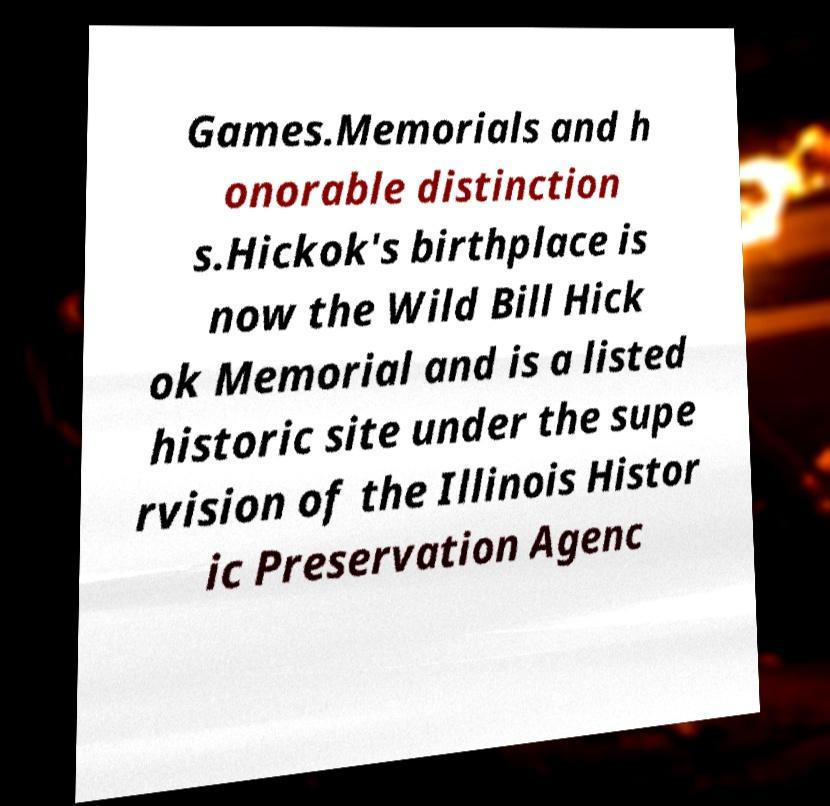Can you accurately transcribe the text from the provided image for me? Games.Memorials and h onorable distinction s.Hickok's birthplace is now the Wild Bill Hick ok Memorial and is a listed historic site under the supe rvision of the Illinois Histor ic Preservation Agenc 